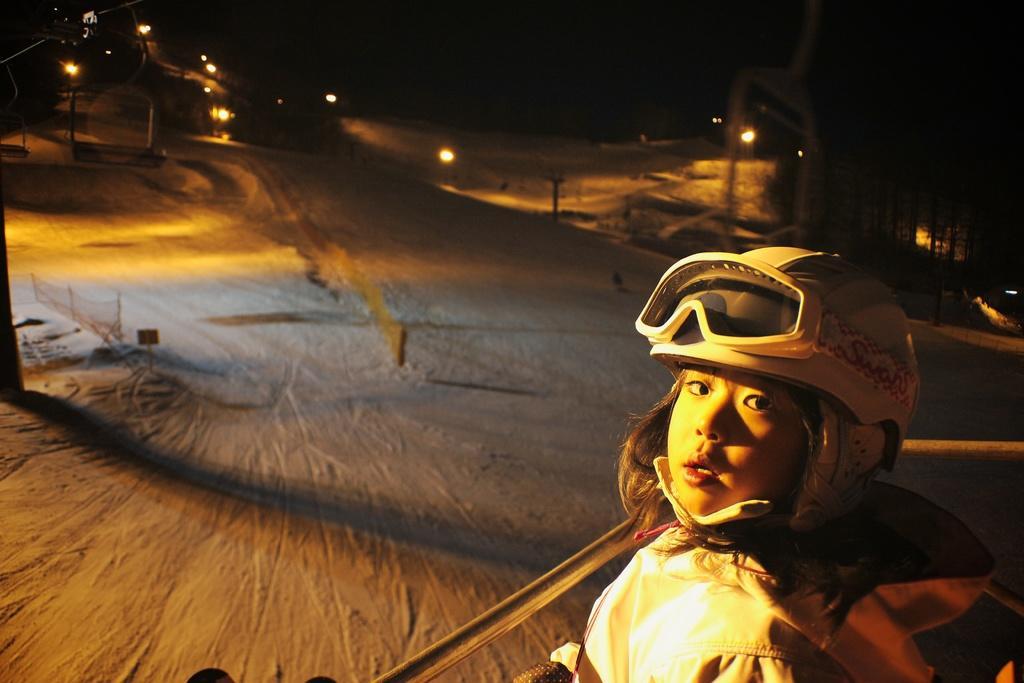In one or two sentences, can you explain what this image depicts? This image clicked in the dark. On the right side there is a girl wearing jacket, helmet on the head and looking at the picture. In front of her there is a metal rod. In the background there is a road and also I can see few lights in the dark. 